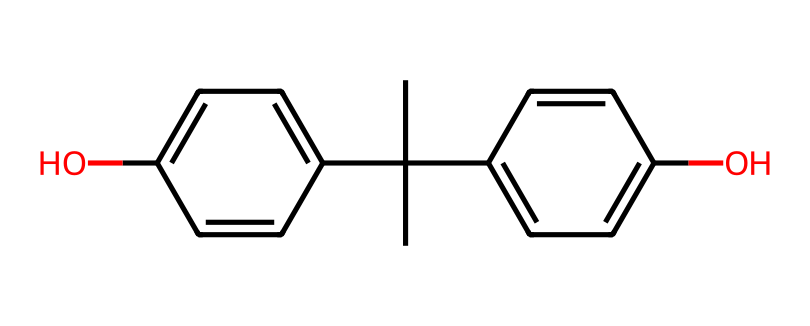What is the molecular formula of this compound? To derive the molecular formula, count the atoms present in the structure. From the SMILES representation, we identify 15 carbon atoms, 16 hydrogen atoms, and 2 oxygen atoms. This gives us a molecular formula of C15H16O2.
Answer: C15H16O2 How many hydroxyl (–OH) groups are in the structure? By analyzing the SMILES representation, we note the presence of two –OH groups attached to carbon atoms within the benzene rings. Thus, there are two hydroxyl groups.
Answer: 2 What type of compound is bisphenol A classified as? Bisphenol A consists of two phenol rings connected by a carbon chain, which characterizes it as a diphenolic compound. Thus, bisphenol A is classified as a phenol.
Answer: phenol How many rings are present in the structure? By examining the structure, we identify two distinct benzene rings. Each ring is integral to the structure of bisphenol A, confirming there are two rings.
Answer: 2 What functional groups are present in this molecule? The functional groups identified in the structure include hydroxyl (–OH) groups. In this case, there are two –OH functional groups resulting from the phenolic nature of the compound.
Answer: hydroxyl groups Does this compound have symmetrical characteristics? The structure shows that the two phenolic units are arranged symmetrically around the central carbon linkage, indicating that the compound’s geometry defines symmetrical characteristics.
Answer: symmetrical 